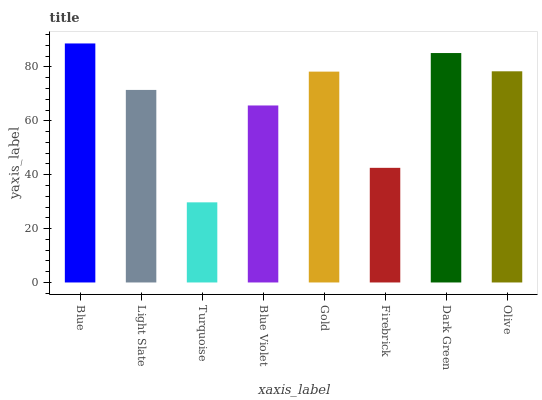Is Turquoise the minimum?
Answer yes or no. Yes. Is Blue the maximum?
Answer yes or no. Yes. Is Light Slate the minimum?
Answer yes or no. No. Is Light Slate the maximum?
Answer yes or no. No. Is Blue greater than Light Slate?
Answer yes or no. Yes. Is Light Slate less than Blue?
Answer yes or no. Yes. Is Light Slate greater than Blue?
Answer yes or no. No. Is Blue less than Light Slate?
Answer yes or no. No. Is Gold the high median?
Answer yes or no. Yes. Is Light Slate the low median?
Answer yes or no. Yes. Is Dark Green the high median?
Answer yes or no. No. Is Firebrick the low median?
Answer yes or no. No. 